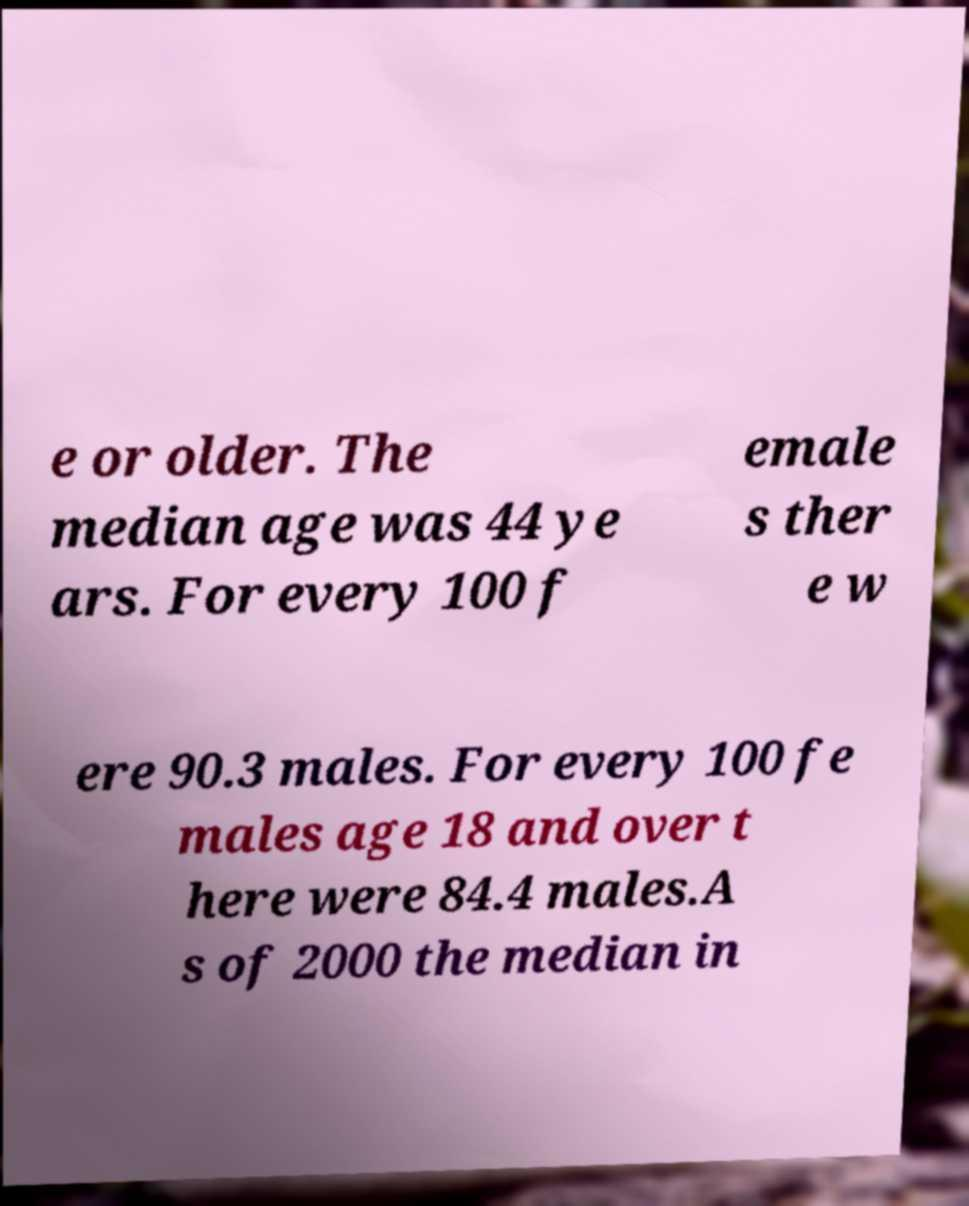Can you accurately transcribe the text from the provided image for me? e or older. The median age was 44 ye ars. For every 100 f emale s ther e w ere 90.3 males. For every 100 fe males age 18 and over t here were 84.4 males.A s of 2000 the median in 